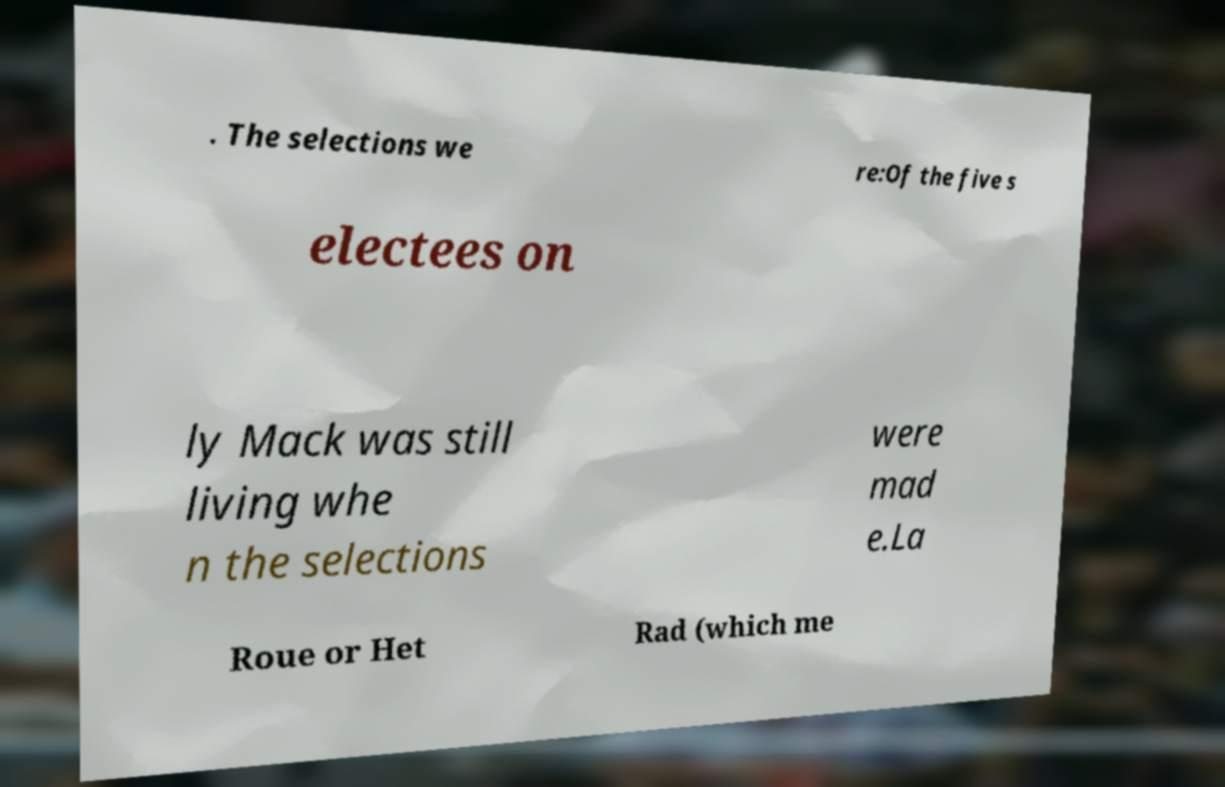For documentation purposes, I need the text within this image transcribed. Could you provide that? . The selections we re:Of the five s electees on ly Mack was still living whe n the selections were mad e.La Roue or Het Rad (which me 